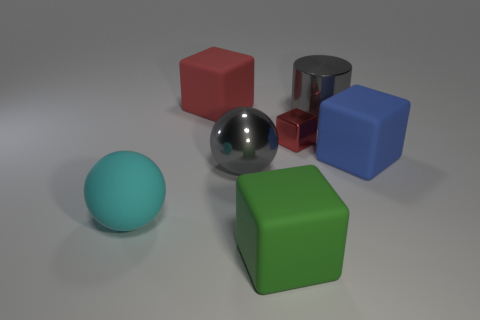Subtract all red blocks. How many were subtracted if there are1red blocks left? 1 Subtract 1 blocks. How many blocks are left? 3 Add 3 large blue matte things. How many objects exist? 10 Subtract all balls. How many objects are left? 5 Add 4 tiny blocks. How many tiny blocks are left? 5 Add 5 cyan rubber balls. How many cyan rubber balls exist? 6 Subtract 0 cyan blocks. How many objects are left? 7 Subtract all gray cylinders. Subtract all blue matte cubes. How many objects are left? 5 